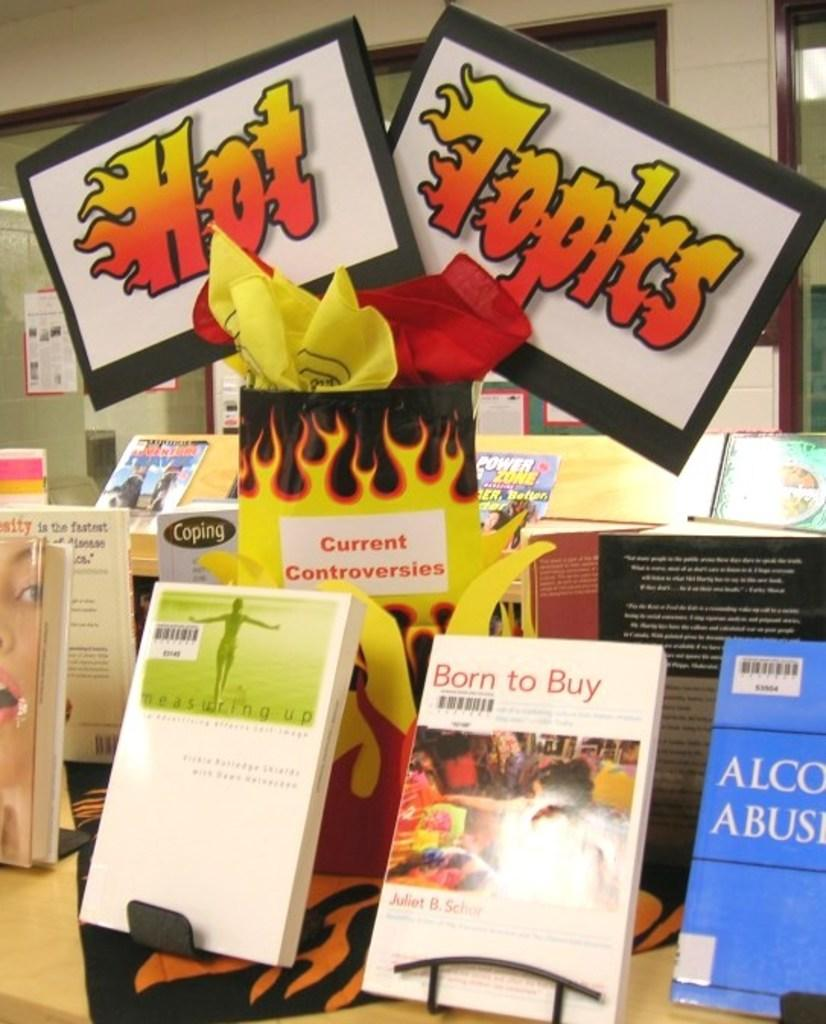<image>
Relay a brief, clear account of the picture shown. A display of books on a table including Born to Buy 